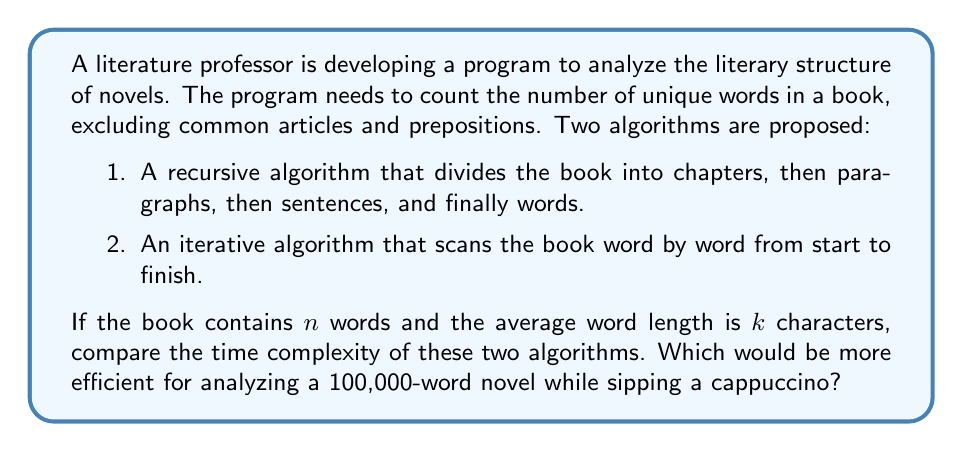Show me your answer to this math problem. To analyze the time complexity of both algorithms, we need to consider their operations:

1. Recursive Algorithm:
   - The algorithm divides the book into smaller parts recursively.
   - At each level of recursion, it processes a subset of words.
   - The total number of recursive calls is proportional to the number of words, $n$.
   - Each word is processed once to check if it's unique and not a common article or preposition.
   - Time complexity: $O(n \log n)$, where the $\log n$ factor comes from the depth of the recursion tree.

2. Iterative Algorithm:
   - The algorithm scans through all words sequentially.
   - Each word is processed once to check if it's unique and not a common article or preposition.
   - Time complexity: $O(n)$

For both algorithms, the process of checking if a word is unique and not a common article or preposition takes constant time on average, assuming a hash set is used for storing unique words.

The space complexity for both algorithms is $O(n)$ in the worst case, where all words are unique.

For a 100,000-word novel:
- Recursive: $O(100000 \log 100000) \approx O(1,660,964)$ operations
- Iterative: $O(100000)$ operations

The iterative algorithm is more efficient, especially for large inputs like a novel. It performs fewer operations and has a simpler implementation, making it the better choice for analyzing a 100,000-word novel while enjoying a cappuccino.
Answer: The iterative algorithm with time complexity $O(n)$ is more efficient for analyzing a 100,000-word novel, performing approximately 100,000 operations compared to the recursive algorithm's 1,660,964 operations. 